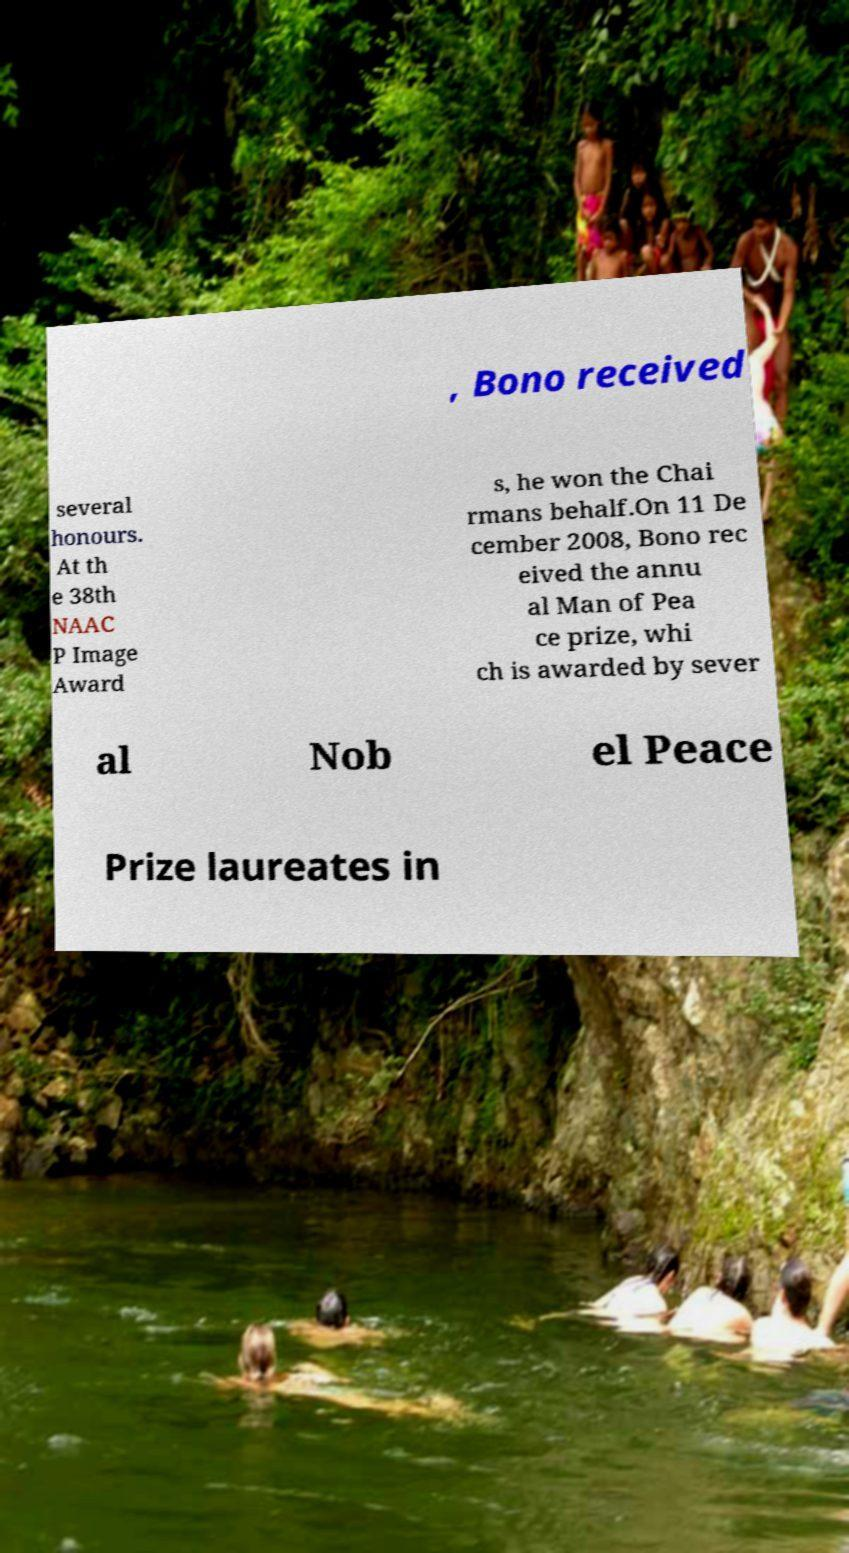What messages or text are displayed in this image? I need them in a readable, typed format. , Bono received several honours. At th e 38th NAAC P Image Award s, he won the Chai rmans behalf.On 11 De cember 2008, Bono rec eived the annu al Man of Pea ce prize, whi ch is awarded by sever al Nob el Peace Prize laureates in 